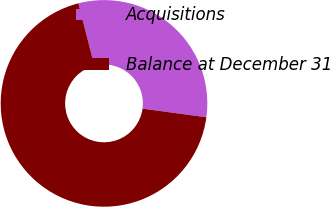Convert chart to OTSL. <chart><loc_0><loc_0><loc_500><loc_500><pie_chart><fcel>Acquisitions<fcel>Balance at December 31<nl><fcel>31.13%<fcel>68.87%<nl></chart> 